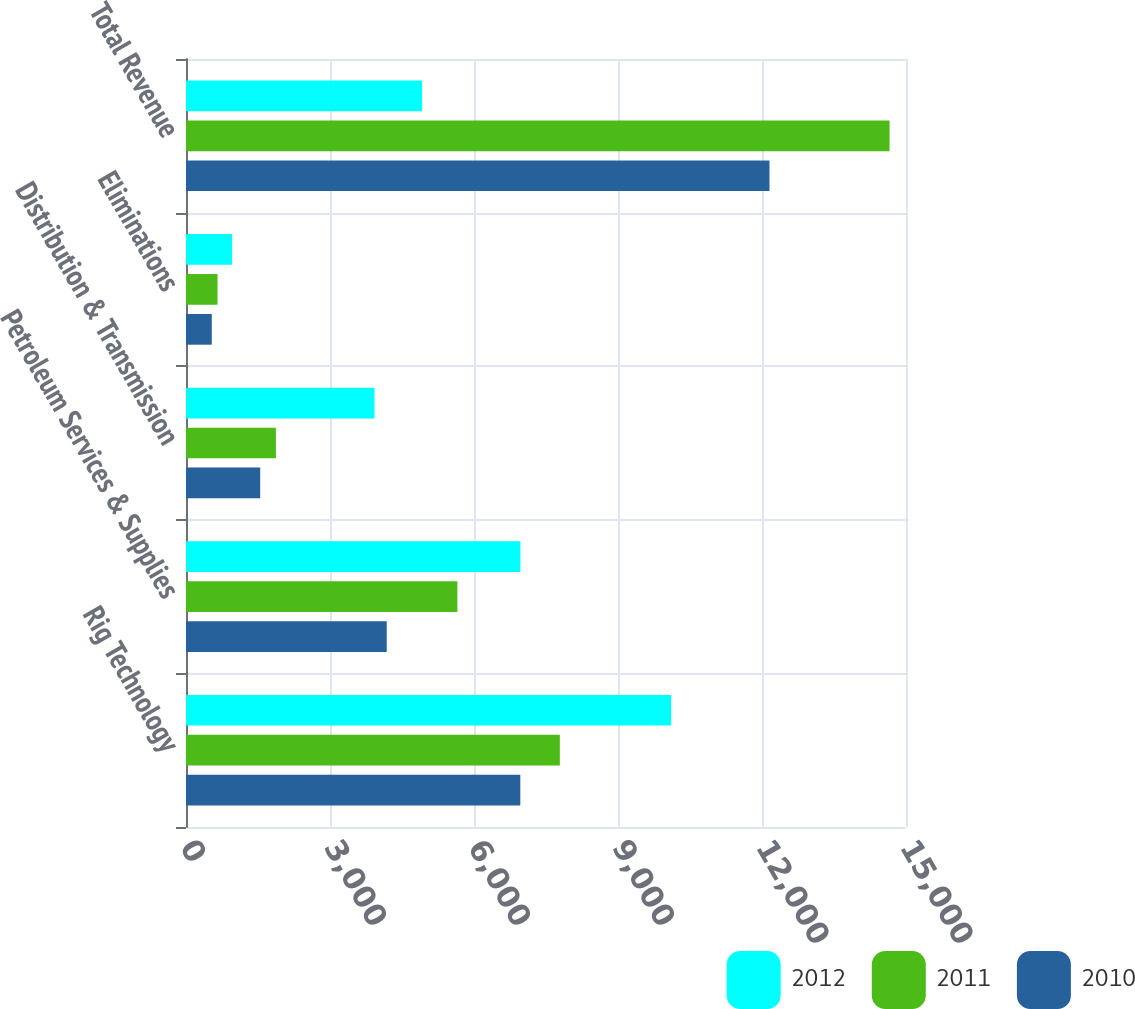Convert chart. <chart><loc_0><loc_0><loc_500><loc_500><stacked_bar_chart><ecel><fcel>Rig Technology<fcel>Petroleum Services & Supplies<fcel>Distribution & Transmission<fcel>Eliminations<fcel>Total Revenue<nl><fcel>2012<fcel>10107<fcel>6967<fcel>3927<fcel>960<fcel>4918<nl><fcel>2011<fcel>7788<fcel>5654<fcel>1873<fcel>657<fcel>14658<nl><fcel>2010<fcel>6965<fcel>4182<fcel>1546<fcel>537<fcel>12156<nl></chart> 